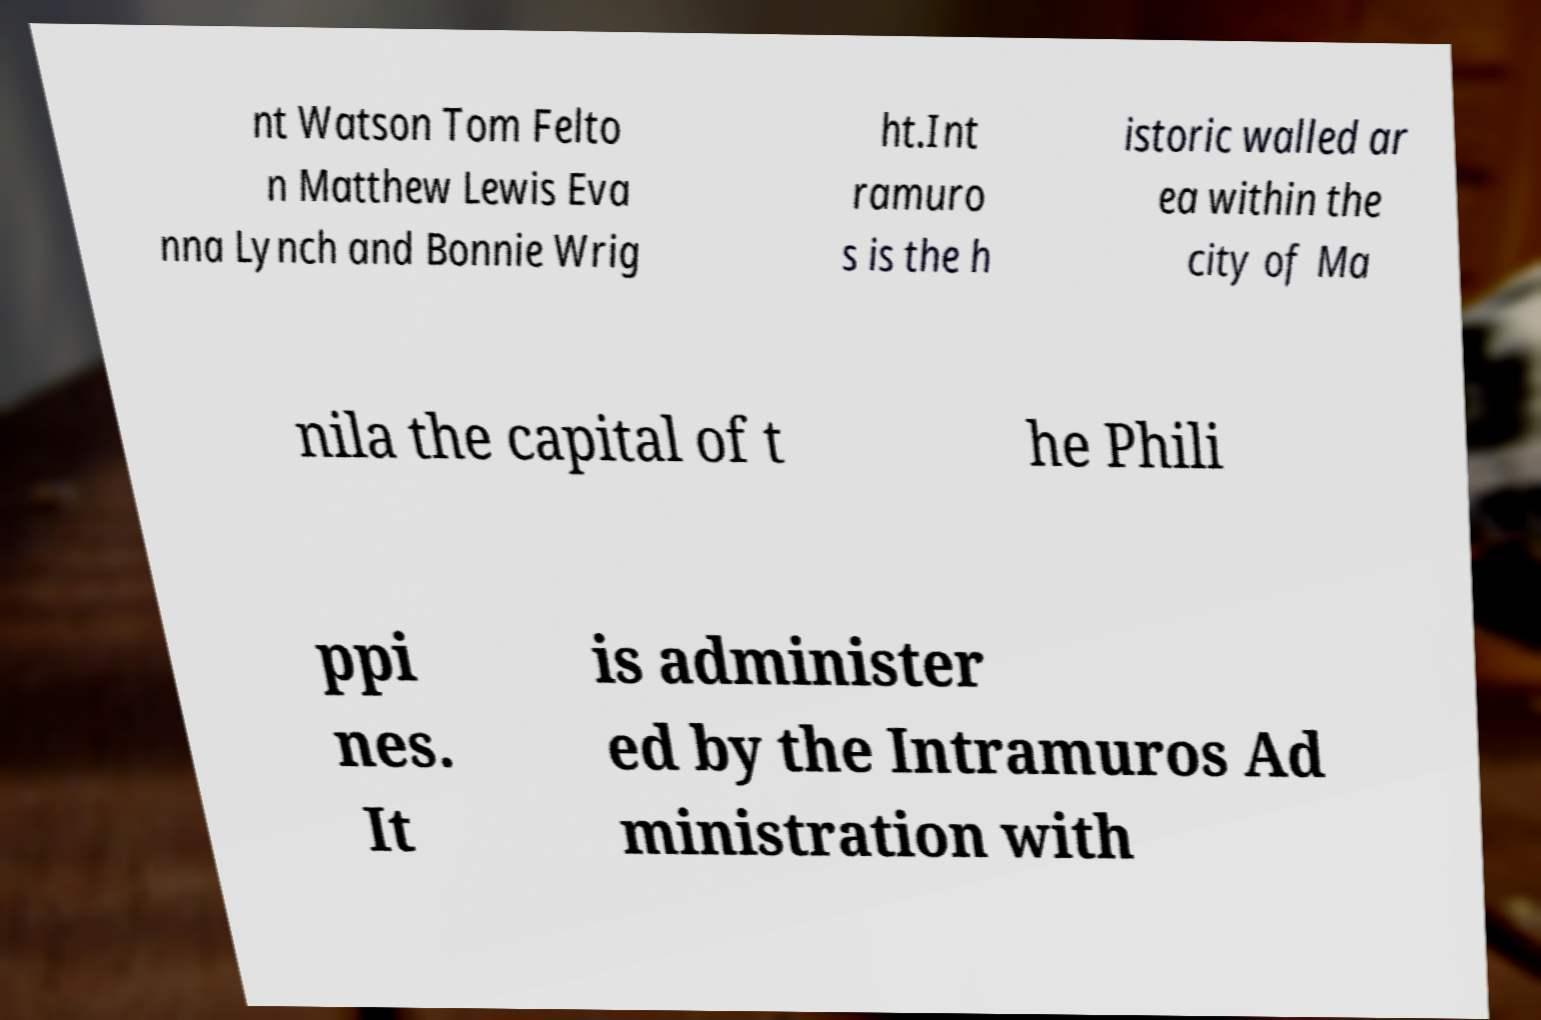Can you read and provide the text displayed in the image?This photo seems to have some interesting text. Can you extract and type it out for me? nt Watson Tom Felto n Matthew Lewis Eva nna Lynch and Bonnie Wrig ht.Int ramuro s is the h istoric walled ar ea within the city of Ma nila the capital of t he Phili ppi nes. It is administer ed by the Intramuros Ad ministration with 